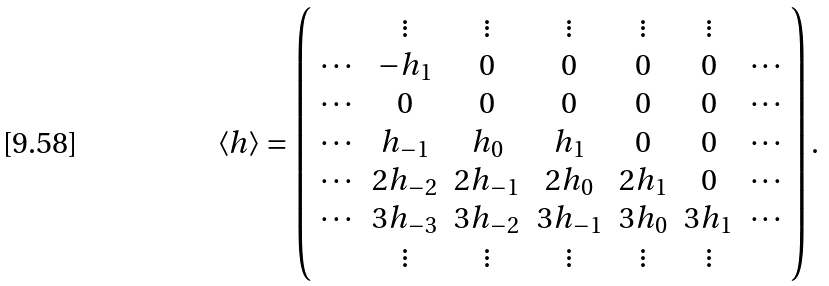<formula> <loc_0><loc_0><loc_500><loc_500>\left < h \right > = \left ( \begin{array} { c c c c c c c c } & \vdots & \vdots & \vdots & \vdots & \vdots & \\ \cdots & - h _ { 1 } & 0 & 0 & 0 & 0 & \cdots \\ \cdots & 0 & 0 & 0 & 0 & 0 & \cdots \\ \cdots & h _ { - 1 } & h _ { 0 } & h _ { 1 } & 0 & 0 & \cdots \\ \cdots & 2 h _ { - 2 } & 2 h _ { - 1 } & 2 h _ { 0 } & 2 h _ { 1 } & 0 & \cdots \\ \cdots & 3 h _ { - 3 } & 3 h _ { - 2 } & 3 h _ { - 1 } & 3 h _ { 0 } & 3 h _ { 1 } & \cdots \\ & \vdots & \vdots & \vdots & \vdots & \vdots & \\ \end{array} \right ) .</formula> 